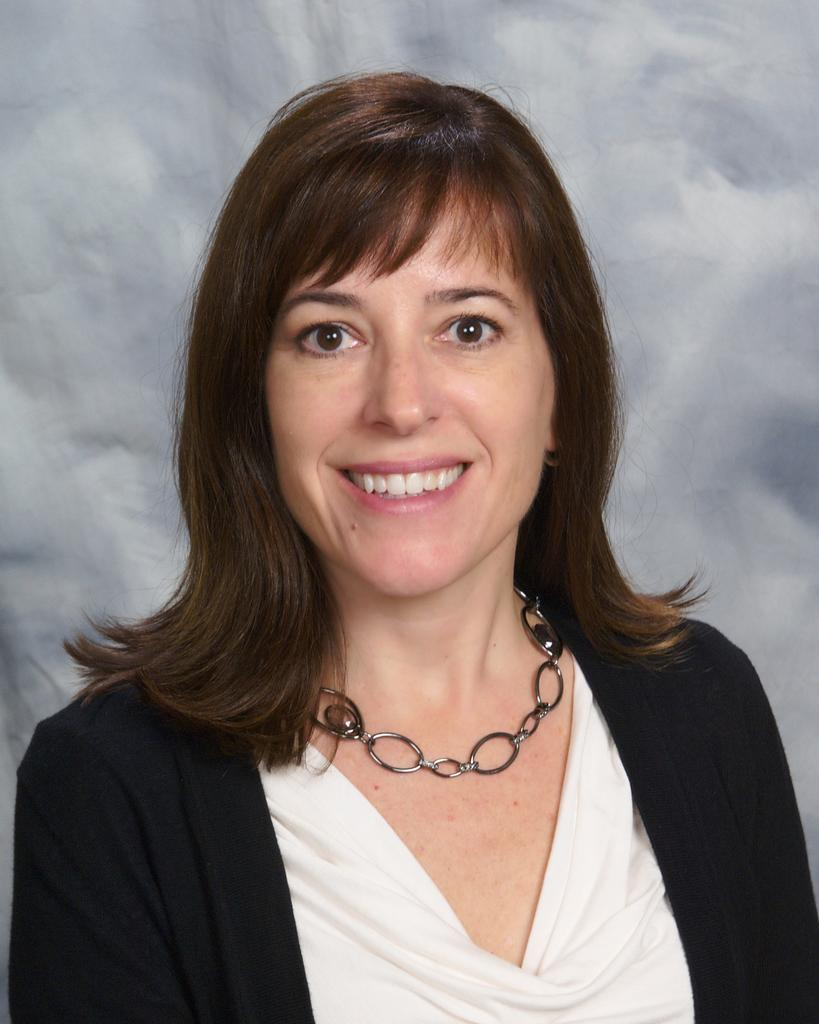Who is the main subject in the image? There is a lady in the center of the image. What is the lady doing in the image? The lady is smiling. What can be seen in the background of the image? There is a wall in the background of the image. What type of yarn is the lady holding during the meeting with the stranger? There is no yarn or meeting with a stranger depicted in the image. 